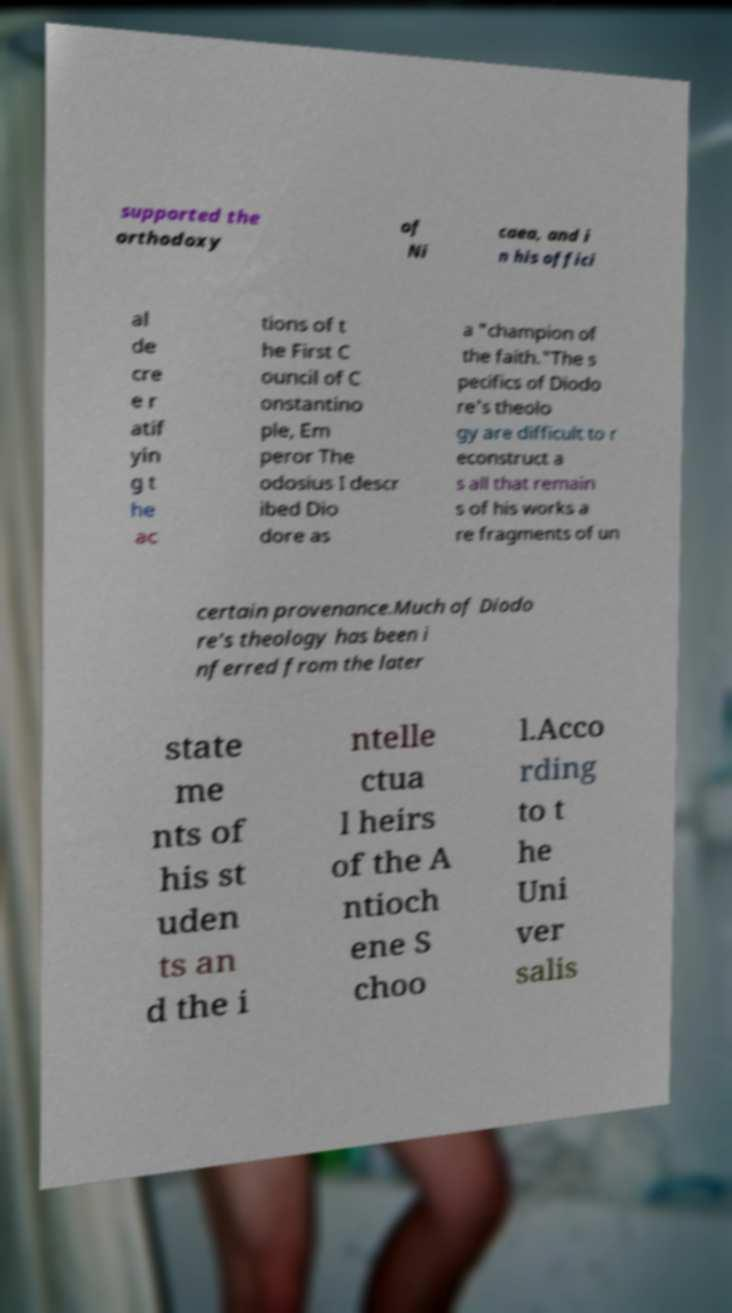What messages or text are displayed in this image? I need them in a readable, typed format. supported the orthodoxy of Ni caea, and i n his offici al de cre e r atif yin g t he ac tions of t he First C ouncil of C onstantino ple, Em peror The odosius I descr ibed Dio dore as a "champion of the faith."The s pecifics of Diodo re's theolo gy are difficult to r econstruct a s all that remain s of his works a re fragments of un certain provenance.Much of Diodo re's theology has been i nferred from the later state me nts of his st uden ts an d the i ntelle ctua l heirs of the A ntioch ene S choo l.Acco rding to t he Uni ver salis 